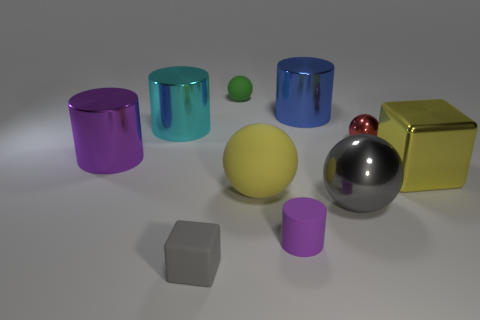Subtract all cylinders. How many objects are left? 6 Add 3 large yellow metallic things. How many large yellow metallic things exist? 4 Subtract 0 blue cubes. How many objects are left? 10 Subtract all big gray metal cylinders. Subtract all big blue things. How many objects are left? 9 Add 6 large gray objects. How many large gray objects are left? 7 